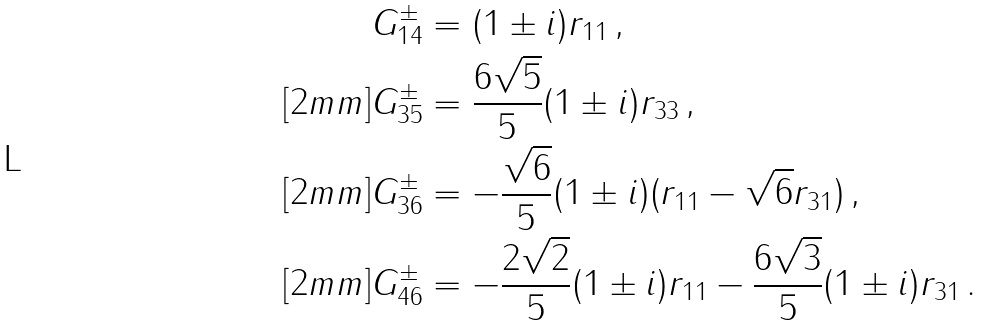Convert formula to latex. <formula><loc_0><loc_0><loc_500><loc_500>G _ { 1 4 } ^ { \pm } & = ( 1 \pm i ) r _ { 1 1 } \, , \\ [ 2 m m ] G _ { 3 5 } ^ { \pm } & = \frac { 6 \sqrt { 5 } } { 5 } ( 1 \pm i ) r _ { 3 3 } \, , \\ [ 2 m m ] G _ { 3 6 } ^ { \pm } & = - \frac { \sqrt { 6 } } { 5 } ( 1 \pm i ) ( r _ { 1 1 } - \sqrt { 6 } r _ { 3 1 } ) \, , \\ [ 2 m m ] G _ { 4 6 } ^ { \pm } & = - \frac { 2 \sqrt { 2 } } { 5 } ( 1 \pm i ) r _ { 1 1 } - \frac { 6 \sqrt { 3 } } { 5 } ( 1 \pm i ) r _ { 3 1 } \, .</formula> 